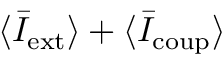<formula> <loc_0><loc_0><loc_500><loc_500>\langle \bar { I } _ { e x t } \rangle + \langle \bar { I } _ { c o u p } \rangle</formula> 